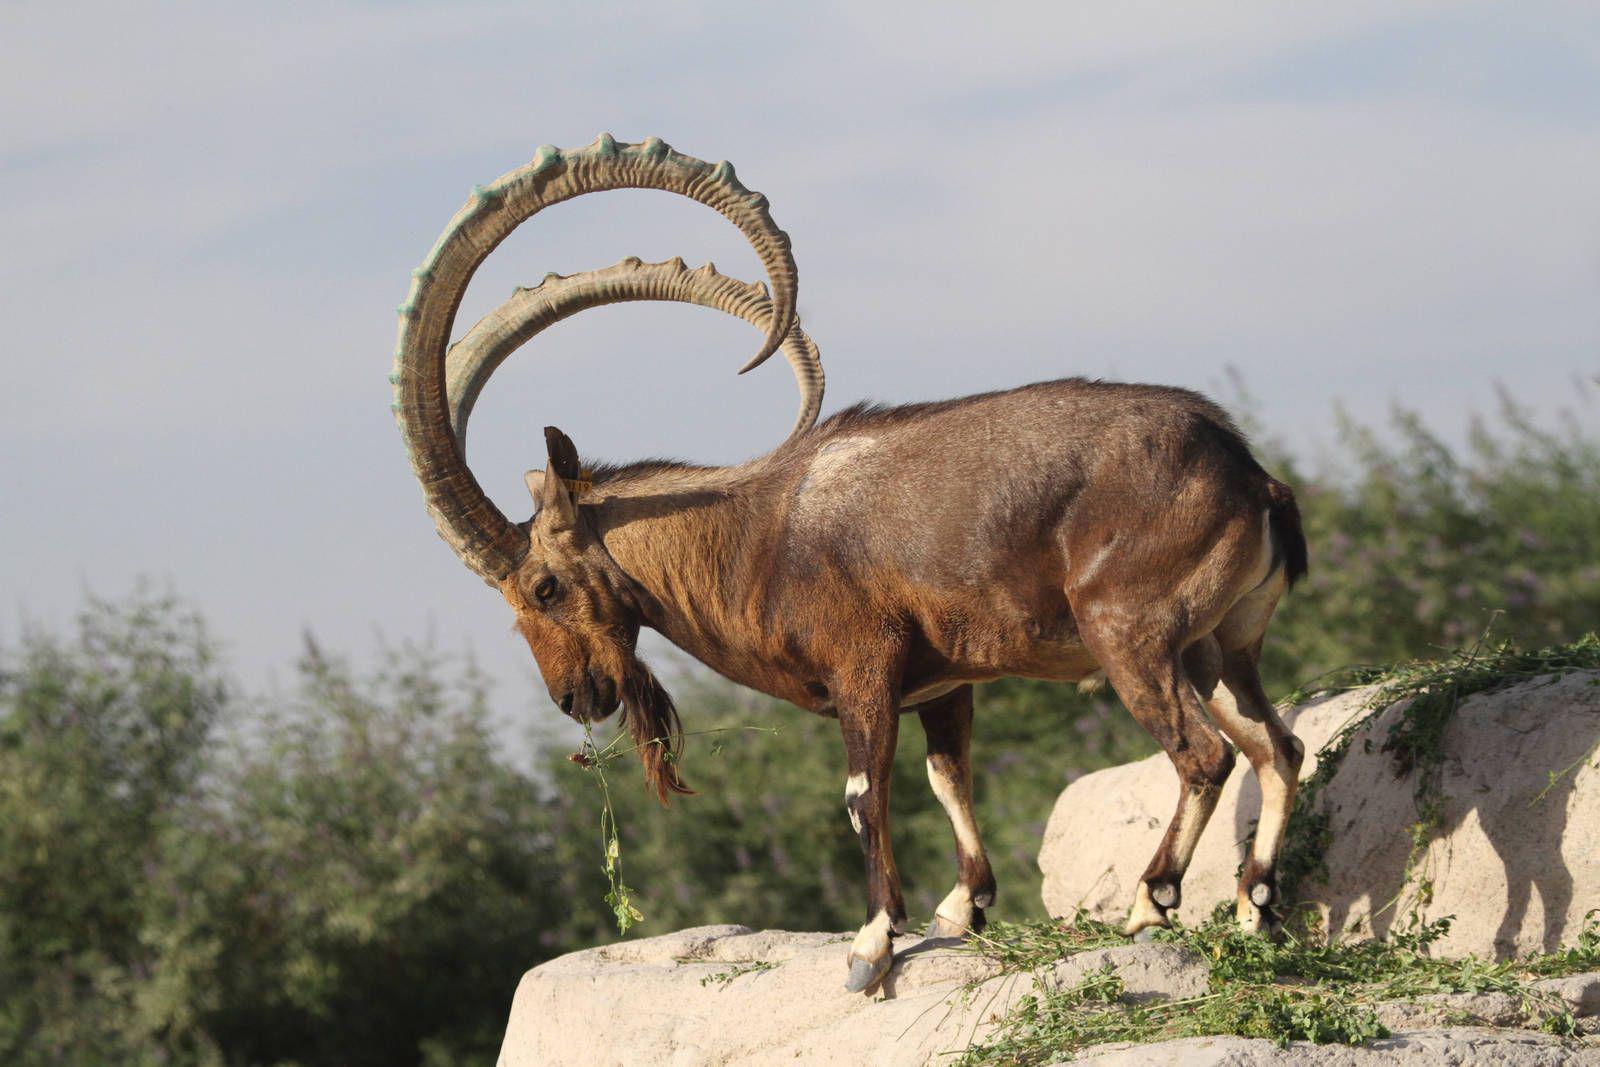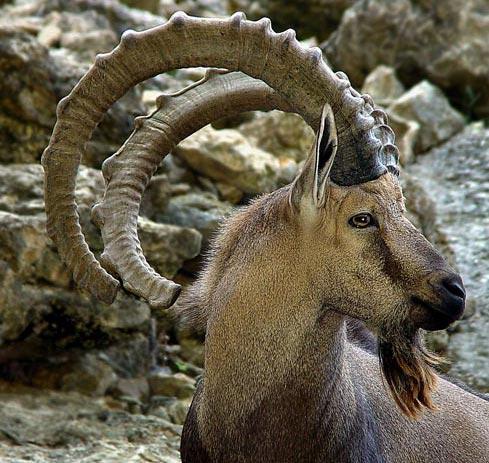The first image is the image on the left, the second image is the image on the right. Evaluate the accuracy of this statement regarding the images: "In 1 of the images, 1 of the goats is seated.". Is it true? Answer yes or no. No. The first image is the image on the left, the second image is the image on the right. Analyze the images presented: Is the assertion "Left image shows a horned animal standing on non-grassy surface with body and head in profile turned leftward." valid? Answer yes or no. Yes. 